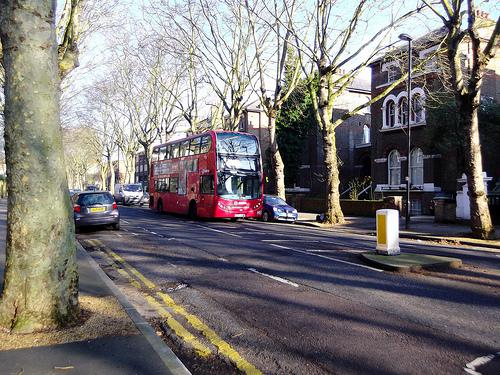Question: why the cars are parked?
Choices:
A. No one using it.
B. There is a concert.
C. They are in the supermarket.
D. They are at work.
Answer with the letter. Answer: A Question: what is the color of the ground?
Choices:
A. Brown.
B. Green.
C. Gray.
D. White.
Answer with the letter. Answer: C Question: how people walking at the sidewalk?
Choices:
A. Five.
B. Ten.
C. Fifteen.
D. Zero.
Answer with the letter. Answer: D Question: where is the bus?
Choices:
A. In the terminal.
B. On the street.
C. On the highway.
D. In the driveway.
Answer with the letter. Answer: B Question: what is the color of the bus?
Choices:
A. Yellow.
B. Black.
C. White.
D. Red.
Answer with the letter. Answer: D 